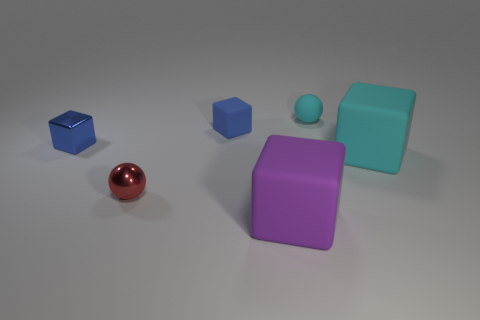What number of balls are either tiny cyan objects or large objects?
Ensure brevity in your answer.  1. There is a small blue thing that is left of the small shiny ball; is it the same shape as the small matte thing that is left of the big purple rubber object?
Give a very brief answer. Yes. What is the small cyan thing made of?
Offer a very short reply. Rubber. What number of purple matte objects have the same size as the rubber sphere?
Your response must be concise. 0. What number of things are either small blue matte cubes behind the large cyan cube or blue blocks that are on the right side of the red metallic sphere?
Provide a short and direct response. 1. Does the tiny ball that is behind the shiny cube have the same material as the block right of the tiny cyan ball?
Ensure brevity in your answer.  Yes. There is a large rubber thing in front of the cyan thing that is in front of the tiny shiny cube; what is its shape?
Offer a very short reply. Cube. Is there anything else that is the same color as the tiny matte ball?
Your response must be concise. Yes. There is a cyan object that is to the left of the big cube that is to the right of the big purple matte cube; is there a purple matte cube that is left of it?
Ensure brevity in your answer.  Yes. Does the tiny sphere that is to the right of the tiny blue matte thing have the same color as the matte cube to the left of the big purple matte block?
Your response must be concise. No. 